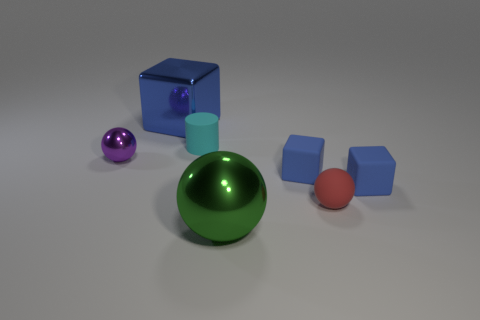Add 2 large things. How many objects exist? 9 Subtract all cylinders. How many objects are left? 6 Subtract 0 green cylinders. How many objects are left? 7 Subtract all green cubes. Subtract all big blue blocks. How many objects are left? 6 Add 1 tiny cylinders. How many tiny cylinders are left? 2 Add 7 small rubber blocks. How many small rubber blocks exist? 9 